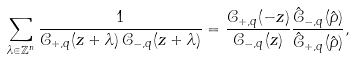<formula> <loc_0><loc_0><loc_500><loc_500>\sum _ { \lambda \in \mathbb { Z } ^ { n } } \frac { 1 } { \mathcal { C } _ { + , q } ( z + \lambda ) \, \mathcal { C } _ { - , q } ( z + \lambda ) } = \frac { \mathcal { C } _ { + , q } ( - z ) } { \mathcal { C } _ { - , q } ( z ) } \frac { \hat { \mathcal { C } } _ { - , q } ( \hat { \rho } ) } { \hat { \mathcal { C } } _ { + , q } ( \hat { \rho } ) } ,</formula> 